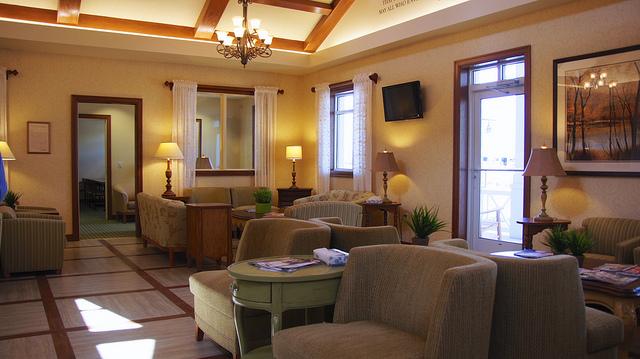How many lamps can you see?
Write a very short answer. 5. What type of room is this?
Write a very short answer. Living room. What is lit in the room?
Concise answer only. Lamps. 